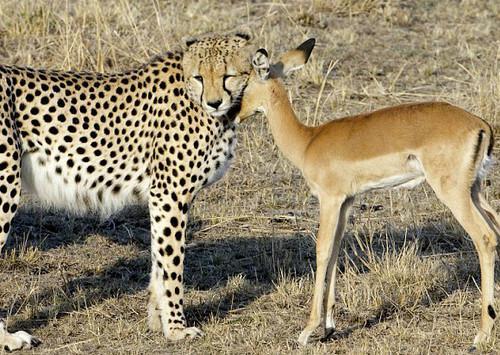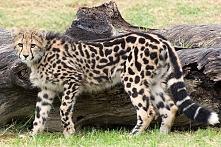The first image is the image on the left, the second image is the image on the right. Analyze the images presented: Is the assertion "The left image shows a close-mouthed cheetah with a ridge of dark hair running from its head like a mane and its body in profile." valid? Answer yes or no. No. The first image is the image on the left, the second image is the image on the right. Examine the images to the left and right. Is the description "There are two animals in total." accurate? Answer yes or no. No. 